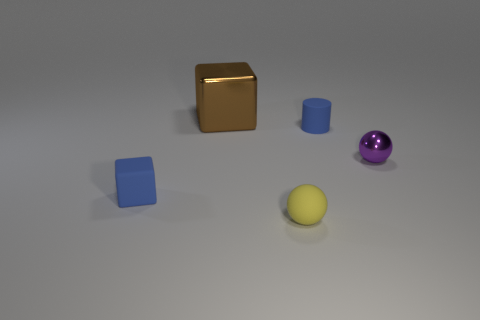Add 2 matte objects. How many objects exist? 7 Add 3 small rubber objects. How many small rubber objects exist? 6 Subtract 0 gray cylinders. How many objects are left? 5 Subtract all blocks. How many objects are left? 3 Subtract all gray cubes. Subtract all yellow balls. How many cubes are left? 2 Subtract all brown things. Subtract all tiny things. How many objects are left? 0 Add 1 yellow objects. How many yellow objects are left? 2 